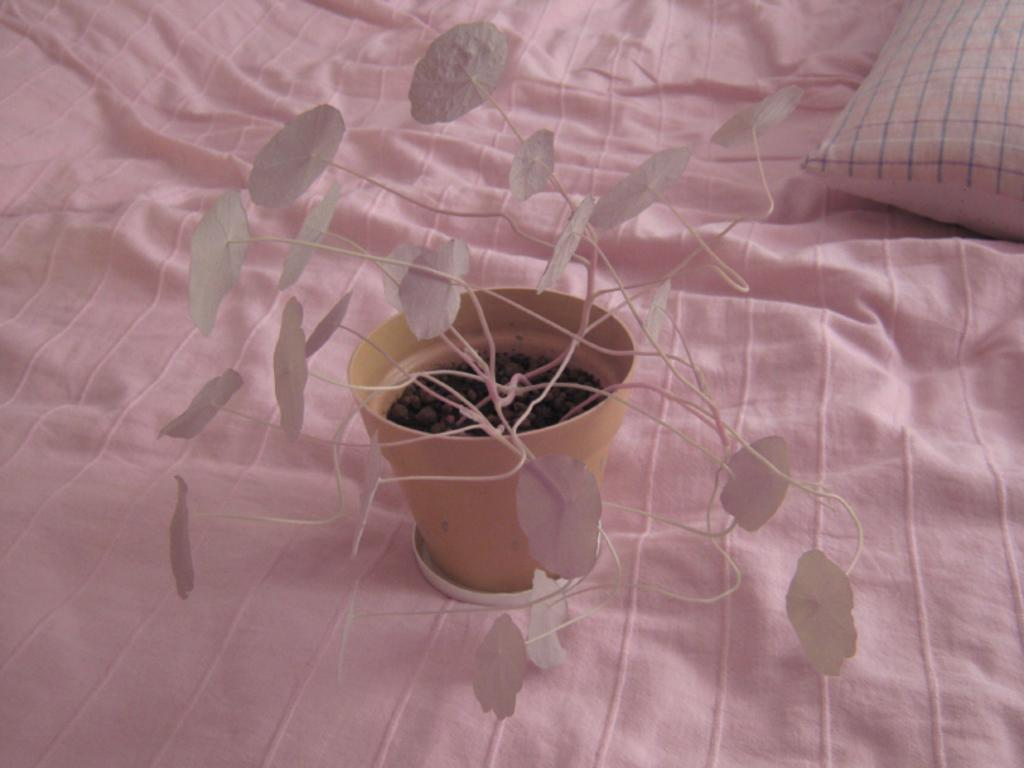What type of plant can be seen in the image? There is a pot plant in the image. What color are the flowers on the pot plant? The pot plant has white flowers. Where is the pot plant located in the image? The pot plant is on a bed. What color is the bed sheet covering the bed? The bed is covered with a pink bed sheet. Can you describe any other objects in the background of the image? There is a pillow in the background of the image. What type of plate is being held by the hands in the image? There are no plates or hands visible in the image; it features a pot plant on a bed with a pink bed sheet and a pillow in the background. 